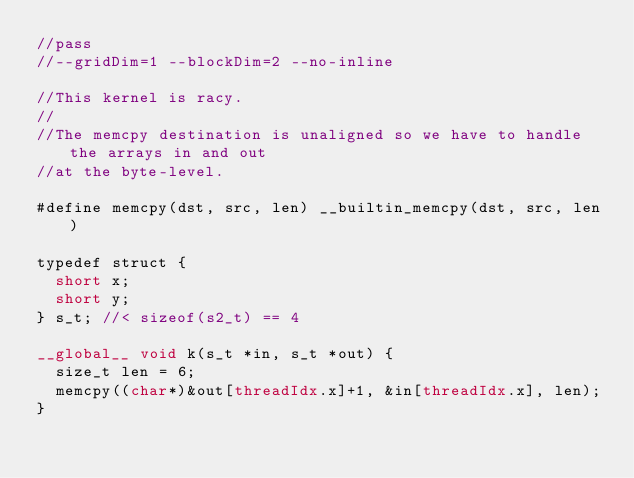Convert code to text. <code><loc_0><loc_0><loc_500><loc_500><_Cuda_>//pass
//--gridDim=1 --blockDim=2 --no-inline

//This kernel is racy.
//
//The memcpy destination is unaligned so we have to handle the arrays in and out
//at the byte-level.

#define memcpy(dst, src, len) __builtin_memcpy(dst, src, len)

typedef struct {
  short x;
  short y;
} s_t; //< sizeof(s2_t) == 4

__global__ void k(s_t *in, s_t *out) {
  size_t len = 6;
  memcpy((char*)&out[threadIdx.x]+1, &in[threadIdx.x], len);
}
</code> 